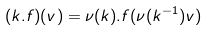Convert formula to latex. <formula><loc_0><loc_0><loc_500><loc_500>( k . f ) ( v ) = \nu ( k ) . f ( \nu ( k ^ { - 1 } ) v )</formula> 